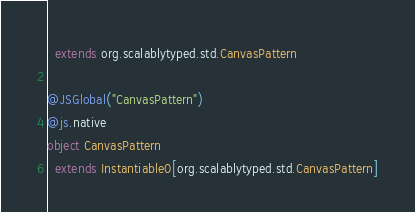Convert code to text. <code><loc_0><loc_0><loc_500><loc_500><_Scala_>  extends org.scalablytyped.std.CanvasPattern

@JSGlobal("CanvasPattern")
@js.native
object CanvasPattern
  extends Instantiable0[org.scalablytyped.std.CanvasPattern]

</code> 